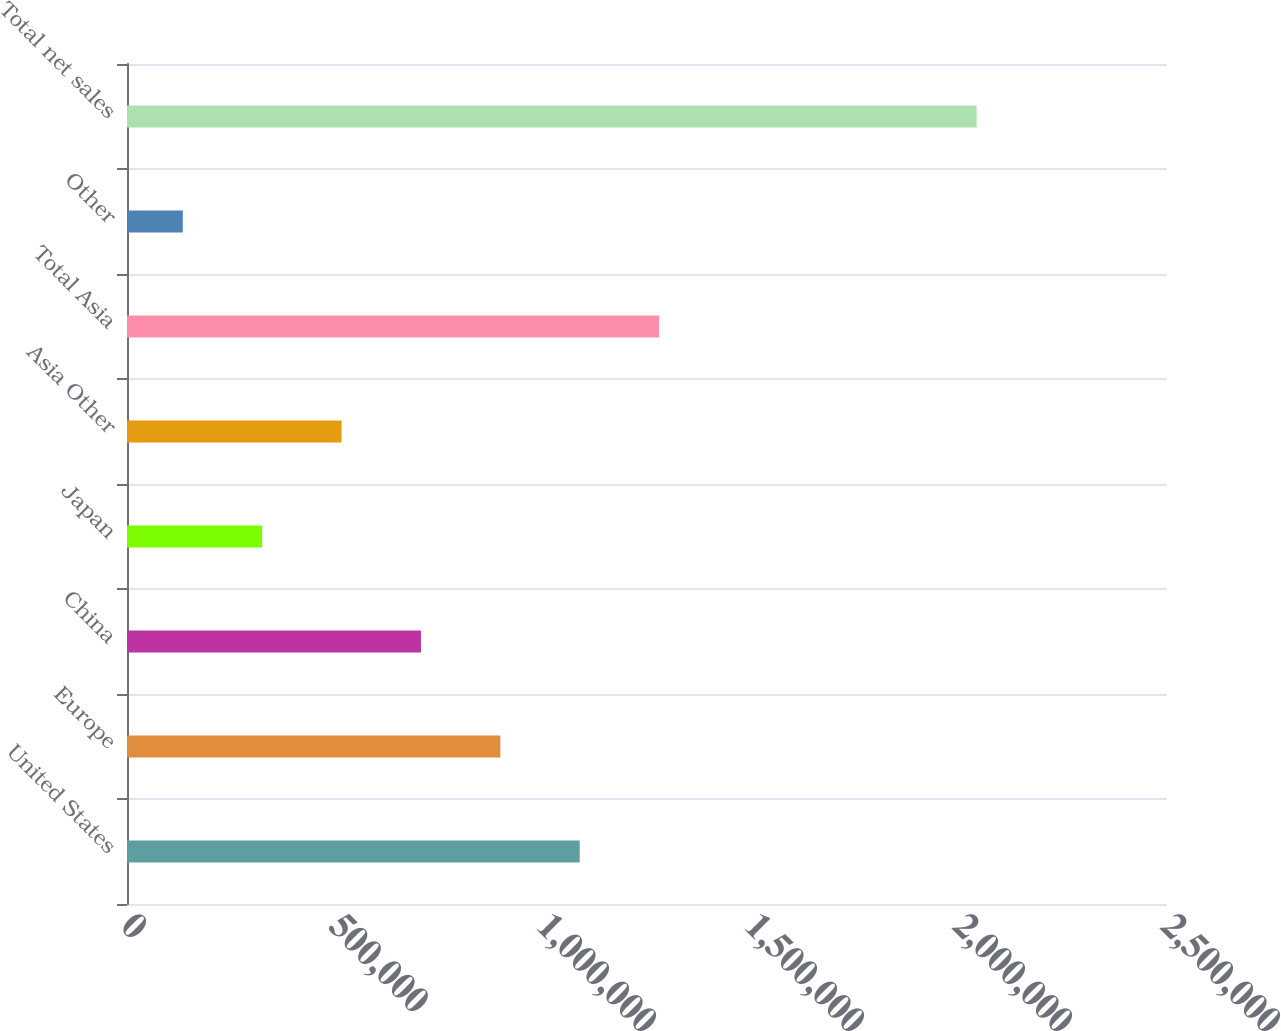Convert chart to OTSL. <chart><loc_0><loc_0><loc_500><loc_500><bar_chart><fcel>United States<fcel>Europe<fcel>China<fcel>Japan<fcel>Asia Other<fcel>Total Asia<fcel>Other<fcel>Total net sales<nl><fcel>1.08823e+06<fcel>897406<fcel>706585<fcel>324943<fcel>515764<fcel>1.27905e+06<fcel>134122<fcel>2.04233e+06<nl></chart> 